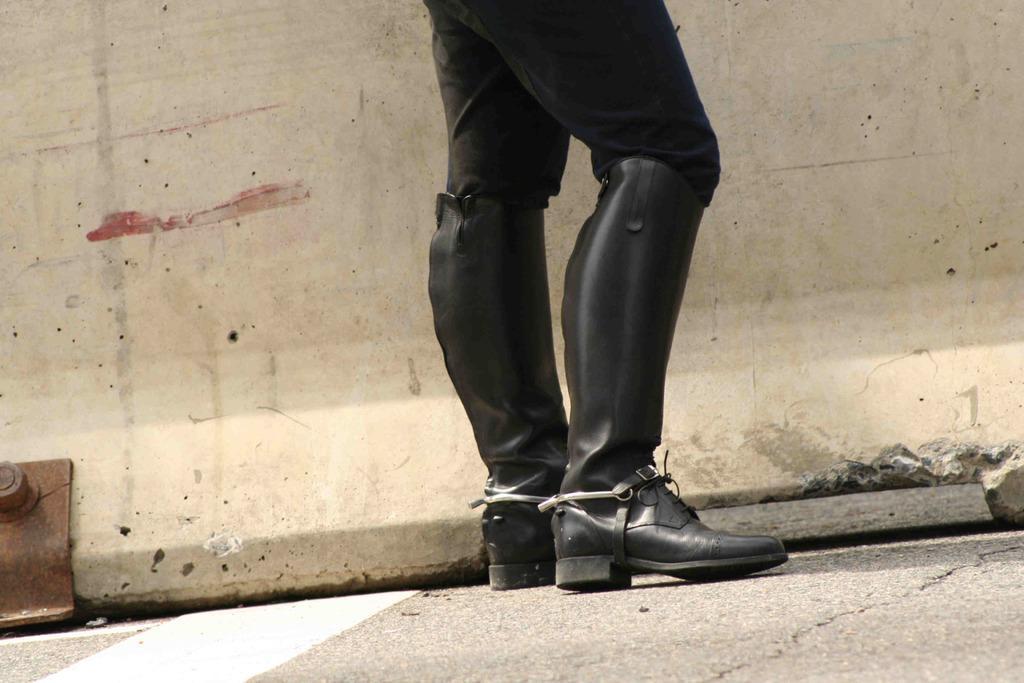How would you summarize this image in a sentence or two? In this picture person is standing on the floor. At the back side there is a wall. 